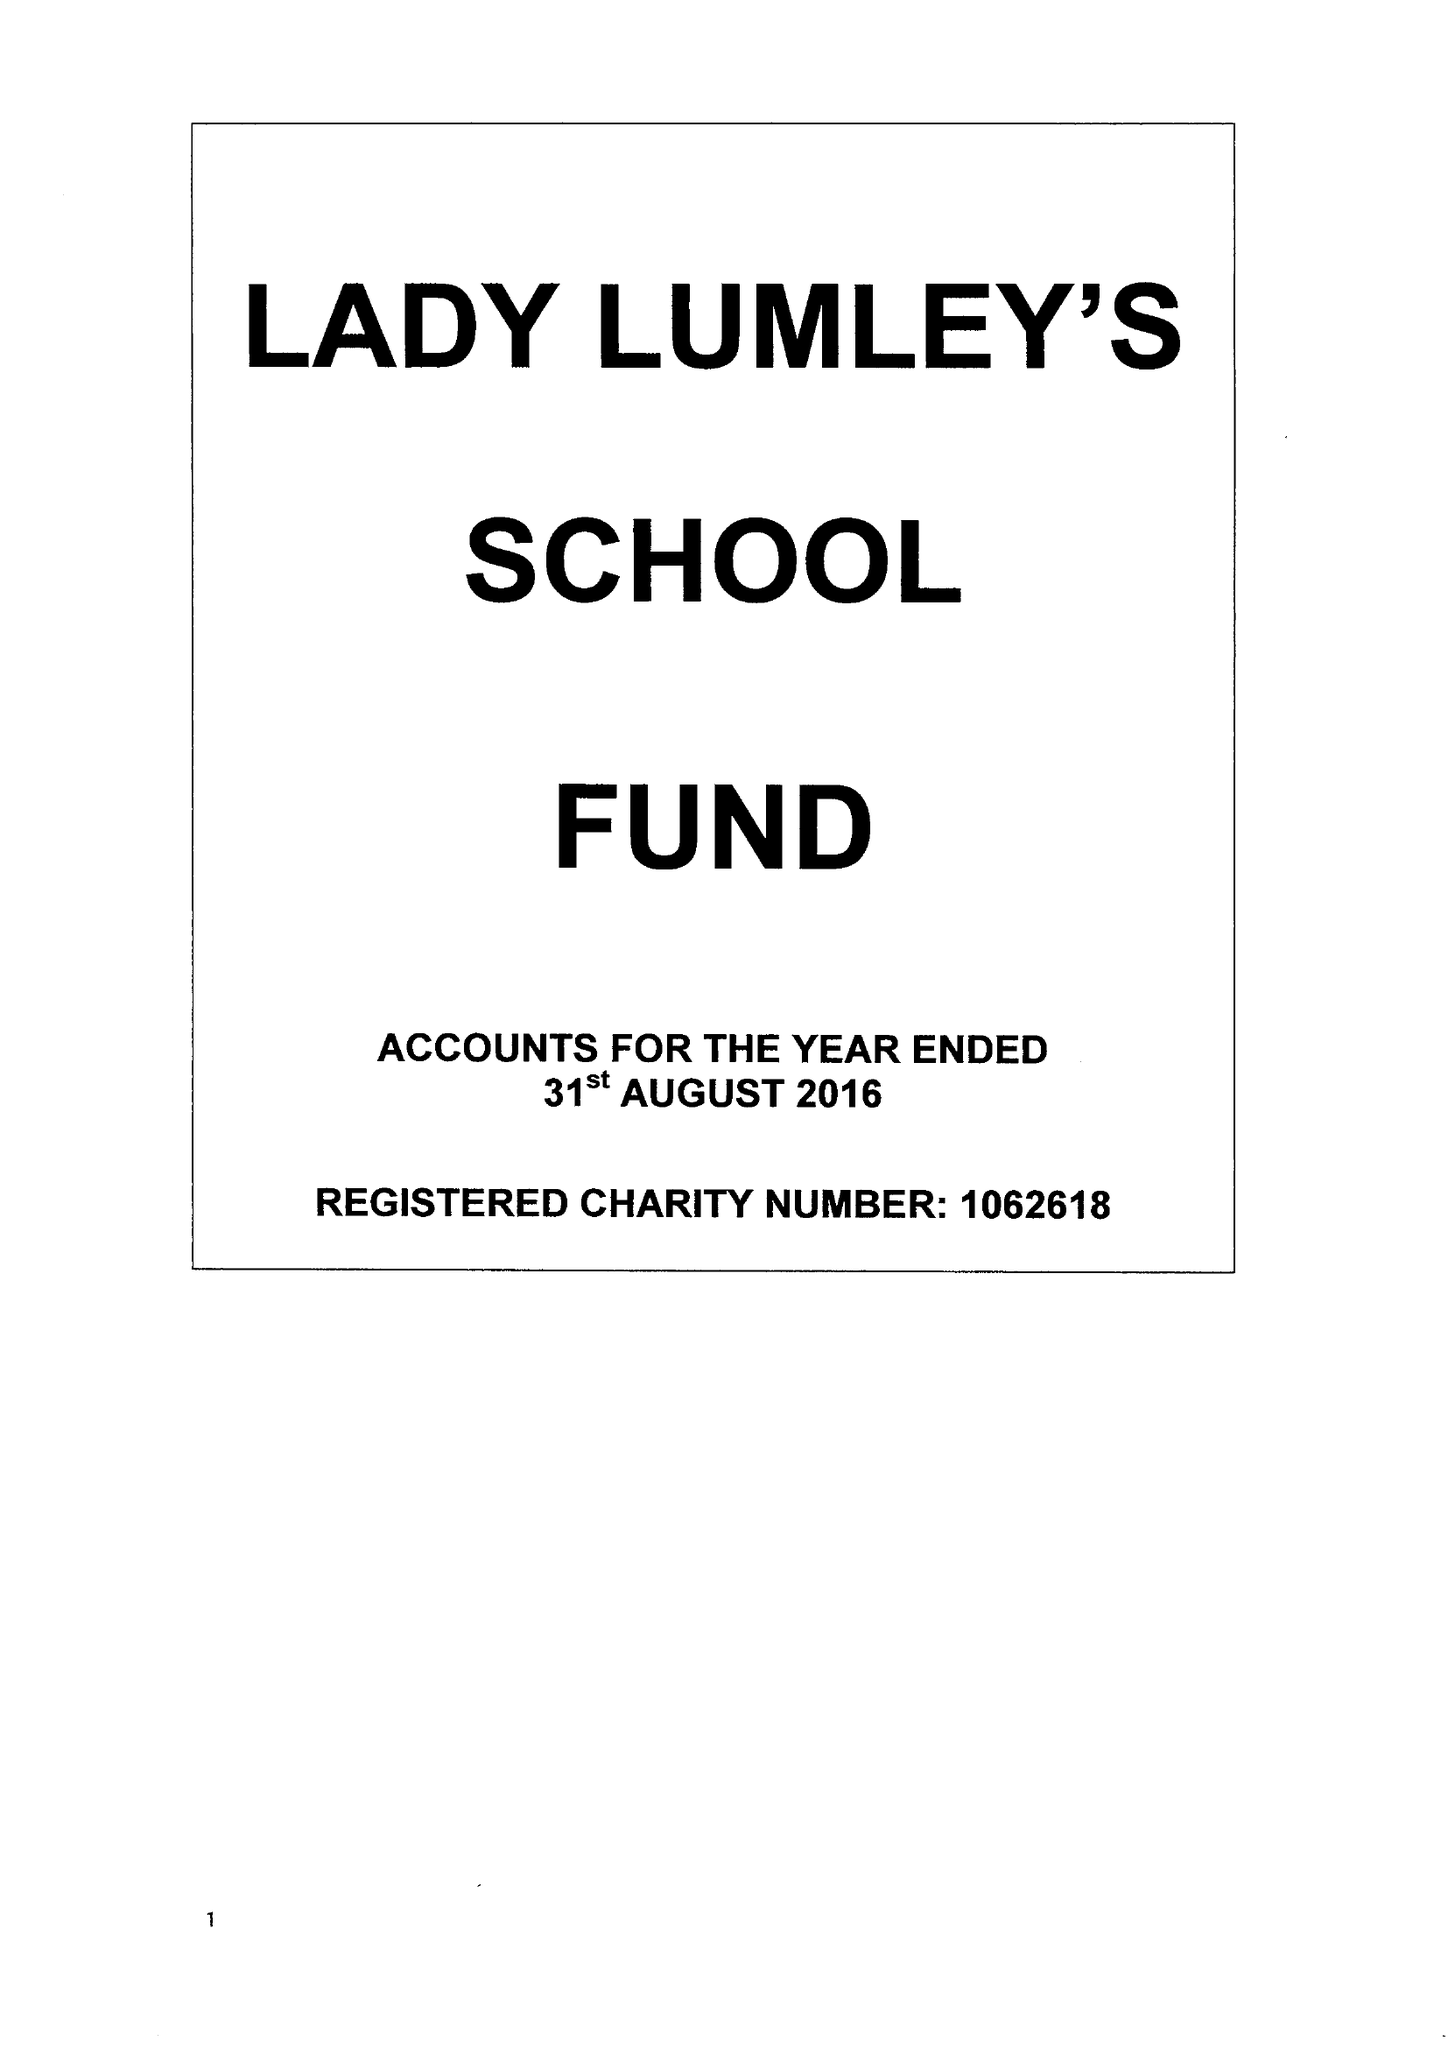What is the value for the charity_name?
Answer the question using a single word or phrase. Lady Lumley's School Fund 